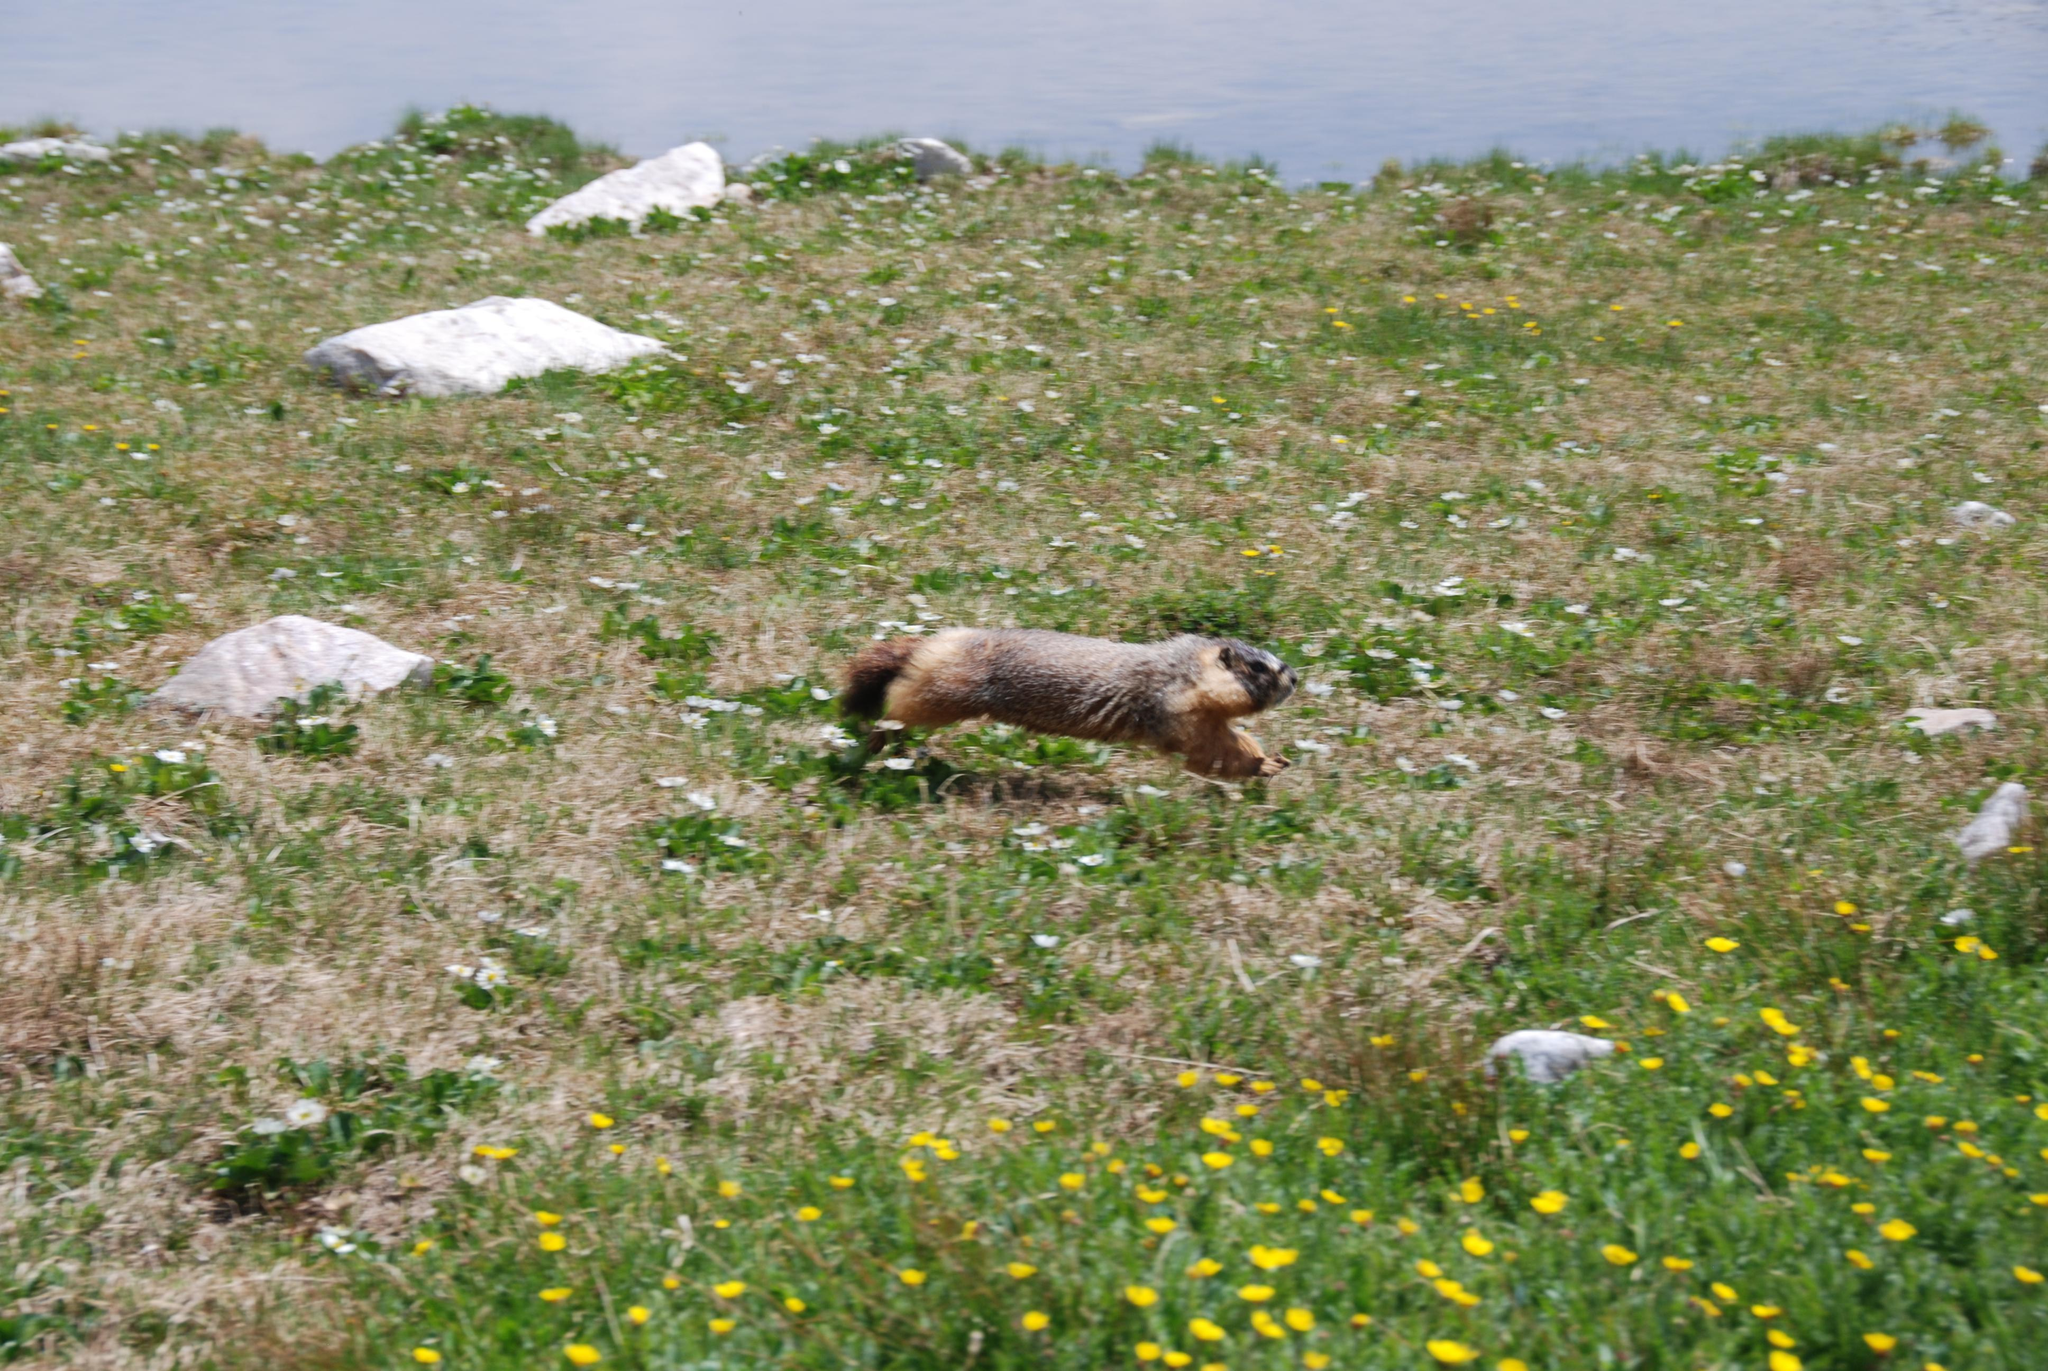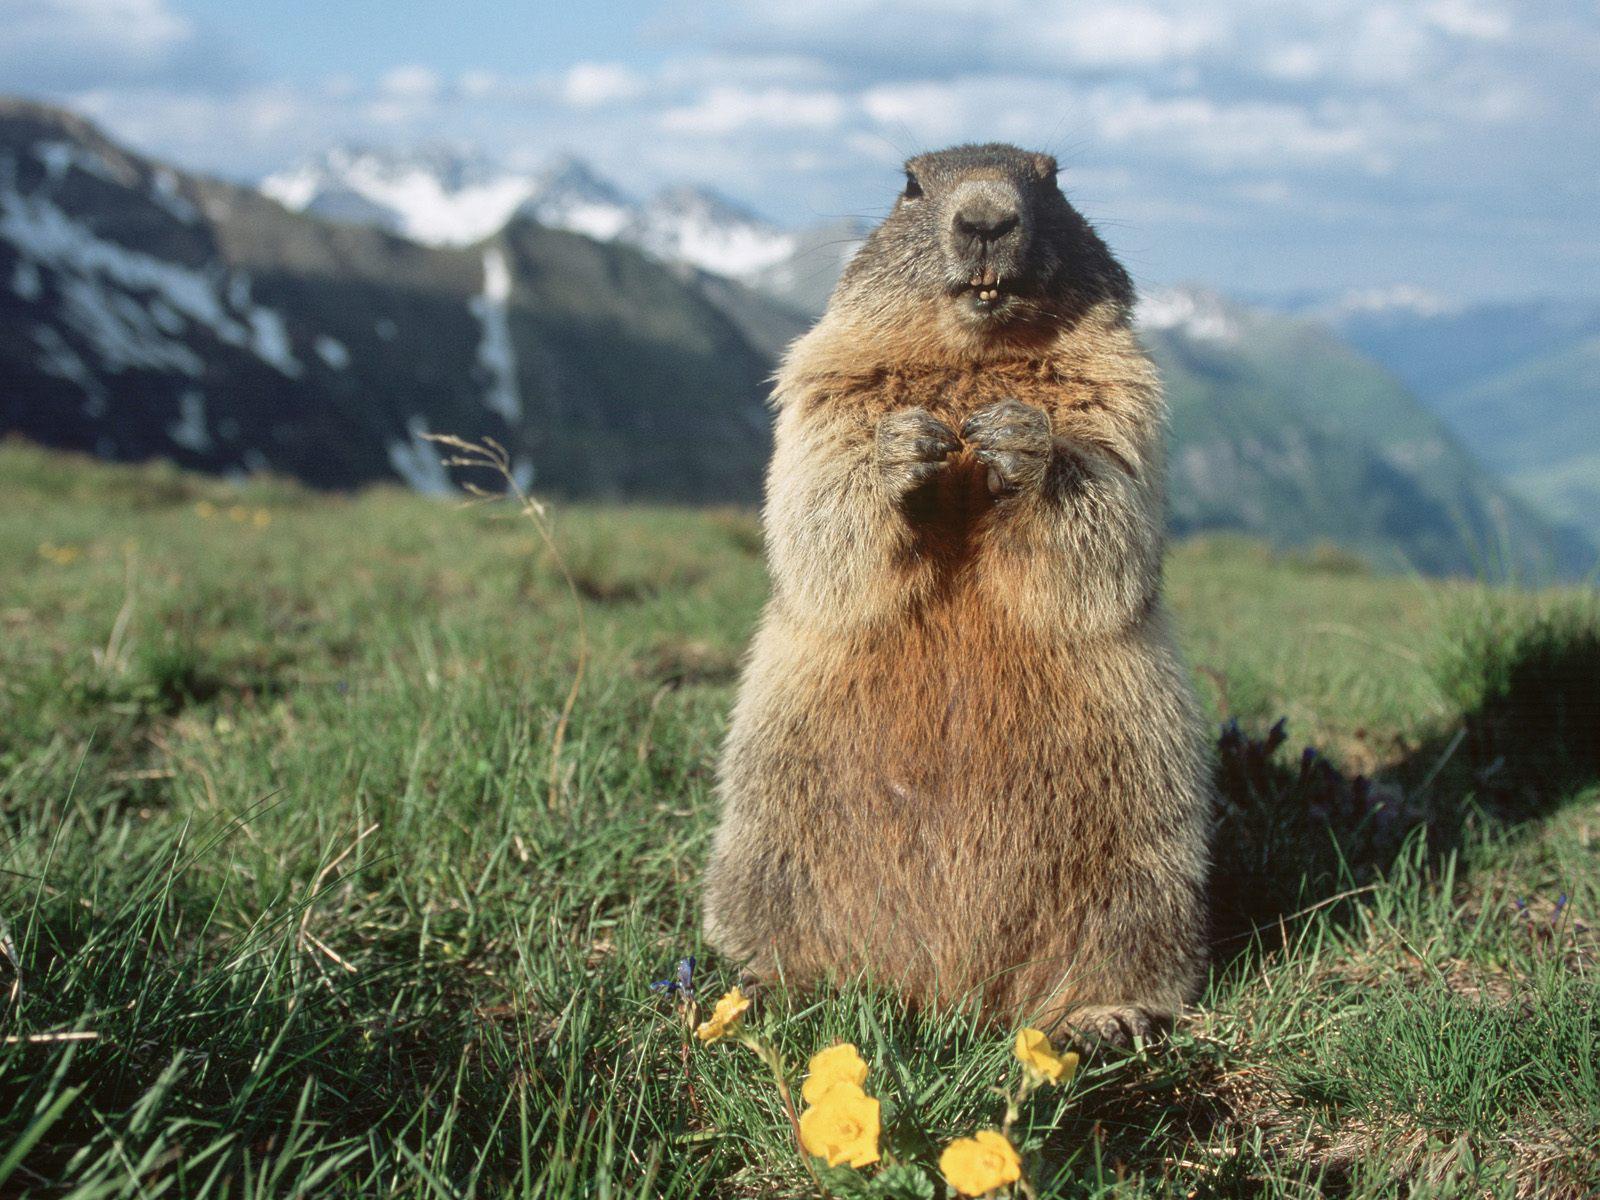The first image is the image on the left, the second image is the image on the right. Assess this claim about the two images: "In one image, a groundhog is standing up on its hind legs.". Correct or not? Answer yes or no. Yes. The first image is the image on the left, the second image is the image on the right. Analyze the images presented: Is the assertion "Exactly one of the images has the animal with its front paws pressed up against a rock while the front paws are elevated higher than it's back paws." valid? Answer yes or no. No. 